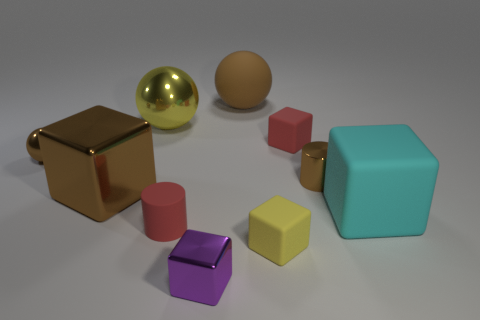There is a sphere that is the same size as the metal cylinder; what is it made of?
Offer a terse response. Metal. How many other objects are the same material as the tiny brown cylinder?
Provide a succinct answer. 4. There is a big thing that is both on the left side of the small brown cylinder and on the right side of the small metal block; what color is it?
Ensure brevity in your answer.  Brown. What number of objects are small objects that are behind the tiny shiny cylinder or tiny brown things?
Offer a terse response. 3. How many other things are there of the same color as the small sphere?
Your answer should be very brief. 3. Are there an equal number of big things behind the small yellow rubber block and big gray rubber blocks?
Give a very brief answer. No. There is a brown shiny object that is on the right side of the small cylinder that is in front of the cyan block; what number of brown objects are on the left side of it?
Ensure brevity in your answer.  3. Does the matte ball have the same size as the red matte thing behind the red rubber cylinder?
Keep it short and to the point. No. How many tiny yellow metal cylinders are there?
Your response must be concise. 0. There is a cyan matte object that is to the right of the small yellow block; is its size the same as the red thing left of the small red block?
Your answer should be very brief. No. 